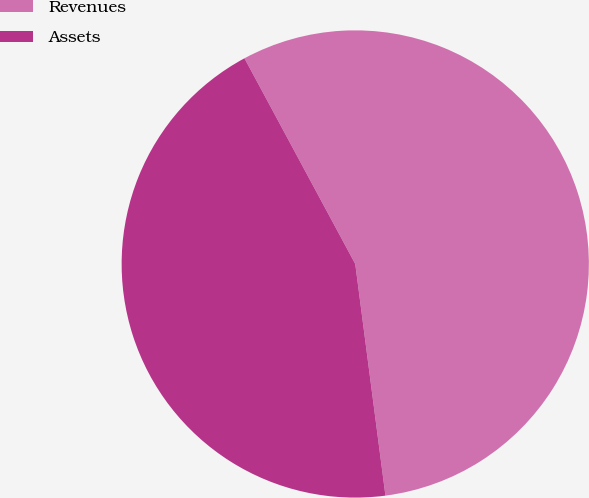Convert chart. <chart><loc_0><loc_0><loc_500><loc_500><pie_chart><fcel>Revenues<fcel>Assets<nl><fcel>55.8%<fcel>44.2%<nl></chart> 